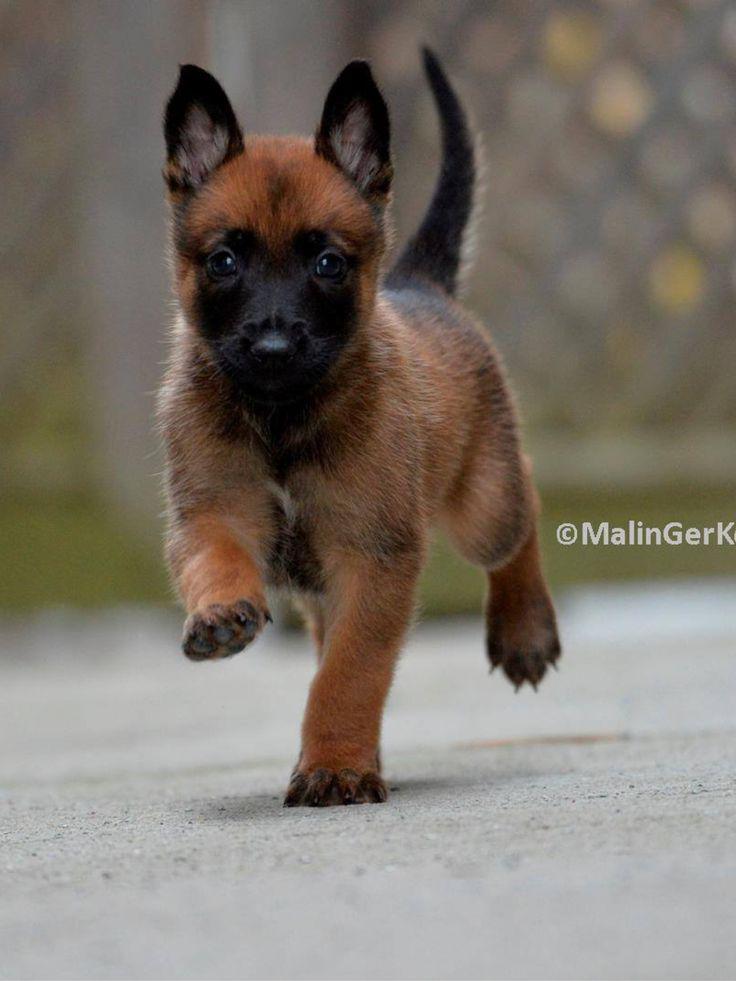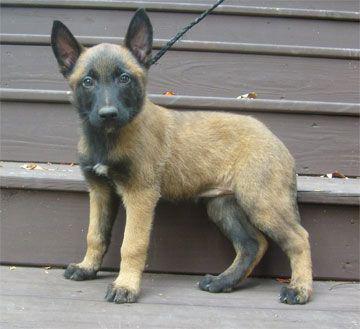The first image is the image on the left, the second image is the image on the right. For the images displayed, is the sentence "A brown puppy has a visible leash." factually correct? Answer yes or no. Yes. The first image is the image on the left, the second image is the image on the right. For the images displayed, is the sentence "A little dog in one image, with ears and tail standing up, has one front paw up in a walking stance." factually correct? Answer yes or no. Yes. 